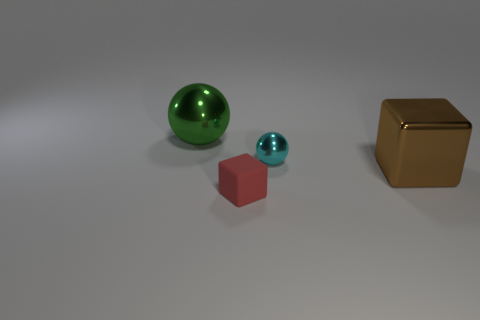Subtract all yellow spheres. Subtract all brown cylinders. How many spheres are left? 2 Add 1 brown shiny things. How many objects exist? 5 Subtract all big rubber cubes. Subtract all small things. How many objects are left? 2 Add 4 green things. How many green things are left? 5 Add 3 big metallic blocks. How many big metallic blocks exist? 4 Subtract 0 blue cylinders. How many objects are left? 4 